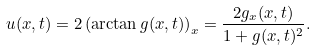Convert formula to latex. <formula><loc_0><loc_0><loc_500><loc_500>u ( x , t ) = 2 \left ( \arctan g ( x , t ) \right ) _ { x } = \frac { 2 g _ { x } ( x , t ) } { 1 + g ( x , t ) ^ { 2 } } .</formula> 